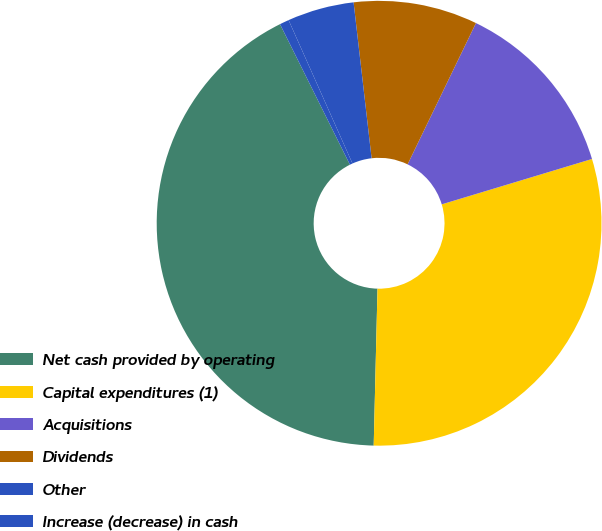Convert chart to OTSL. <chart><loc_0><loc_0><loc_500><loc_500><pie_chart><fcel>Net cash provided by operating<fcel>Capital expenditures (1)<fcel>Acquisitions<fcel>Dividends<fcel>Other<fcel>Increase (decrease) in cash<nl><fcel>42.26%<fcel>30.05%<fcel>13.16%<fcel>9.0%<fcel>4.84%<fcel>0.68%<nl></chart> 